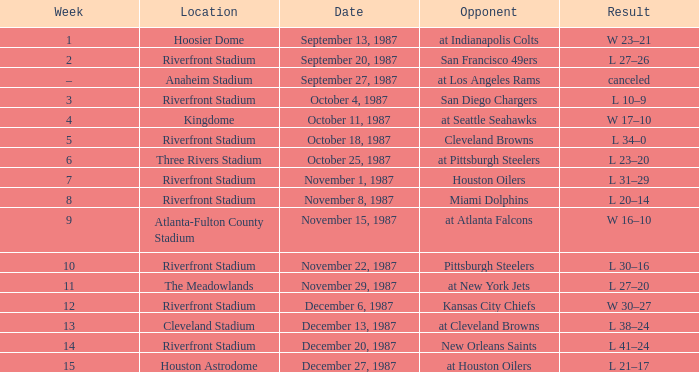What was the result of the game against the Miami Dolphins held at the Riverfront Stadium? L 20–14. Write the full table. {'header': ['Week', 'Location', 'Date', 'Opponent', 'Result'], 'rows': [['1', 'Hoosier Dome', 'September 13, 1987', 'at Indianapolis Colts', 'W 23–21'], ['2', 'Riverfront Stadium', 'September 20, 1987', 'San Francisco 49ers', 'L 27–26'], ['–', 'Anaheim Stadium', 'September 27, 1987', 'at Los Angeles Rams', 'canceled'], ['3', 'Riverfront Stadium', 'October 4, 1987', 'San Diego Chargers', 'L 10–9'], ['4', 'Kingdome', 'October 11, 1987', 'at Seattle Seahawks', 'W 17–10'], ['5', 'Riverfront Stadium', 'October 18, 1987', 'Cleveland Browns', 'L 34–0'], ['6', 'Three Rivers Stadium', 'October 25, 1987', 'at Pittsburgh Steelers', 'L 23–20'], ['7', 'Riverfront Stadium', 'November 1, 1987', 'Houston Oilers', 'L 31–29'], ['8', 'Riverfront Stadium', 'November 8, 1987', 'Miami Dolphins', 'L 20–14'], ['9', 'Atlanta-Fulton County Stadium', 'November 15, 1987', 'at Atlanta Falcons', 'W 16–10'], ['10', 'Riverfront Stadium', 'November 22, 1987', 'Pittsburgh Steelers', 'L 30–16'], ['11', 'The Meadowlands', 'November 29, 1987', 'at New York Jets', 'L 27–20'], ['12', 'Riverfront Stadium', 'December 6, 1987', 'Kansas City Chiefs', 'W 30–27'], ['13', 'Cleveland Stadium', 'December 13, 1987', 'at Cleveland Browns', 'L 38–24'], ['14', 'Riverfront Stadium', 'December 20, 1987', 'New Orleans Saints', 'L 41–24'], ['15', 'Houston Astrodome', 'December 27, 1987', 'at Houston Oilers', 'L 21–17']]} 